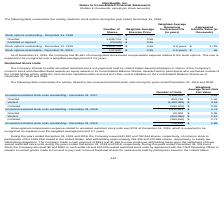According to Nanthealth's financial document, What is the value of unrecognized stock-based compensation expense related to the stock options at December 31, 2019? According to the financial document, $1,641 (in thousands). The relevant text states: "As of December 31, 2019, the Company had $1,641 of unrecognized stock-based compensation expense related to the stock options. This cost is..." Also, What are the respective stock options outstanding and exercisable at December 31, 2019? The document shows two values: 5,815,724 and 137,500. From the document: "Stock options exercisable - December 31, 2019 137,500 $ 0.55 9.6 years $ 66 Stock options outstanding - December 31, 2019 5,815,724 $ 0.56 9.6 years $..." Also, What are the weighted-average exercise price of the stock options outstanding and exercisable at December 31, 2019? The document shows two values: $0.56 and $0.55. From the document: "Granted 5,835,724 $ 0.56 Forfeited or expired (20,000) $ 0.55..." Also, can you calculate: What is the value of the stock options granted as a percentage of the total stock options outstanding as at December 31, 2019? Based on the calculation: 5,835,724/5,815,724 , the result is 100.34 (percentage). This is based on the information: "Stock options outstanding - December 31, 2019 5,815,724 $ 0.56 9.6 years $ 2,725 Granted 5,835,724 $ 0.56..." The key data points involved are: 5,815,724, 5,835,724. Also, can you calculate: What is the average number of stocks outstanding as at December 31, 2018 and 2019? To answer this question, I need to perform calculations using the financial data. The calculation is: (5,815,724 + 0)/2  , which equals 2907862. This is based on the information: "Stock options outstanding - December 31, 2018 — $ — Stock options outstanding - December 31, 2019 5,815,724 $ 0.56 9.6 years $ 2,725 Stock options outstanding - December 31, 2018 — $ —..." The key data points involved are: 5,815,724. Also, can you calculate: What is the total number of stocks outstanding as at December 31, 2018 and 2019? Based on the calculation: 5,815,724 + 0 , the result is 5815724. This is based on the information: "Stock options outstanding - December 31, 2019 5,815,724 $ 0.56 9.6 years $ 2,725 Stock options outstanding - December 31, 2019 5,815,724 $ 0.56 9.6 years $ 2,725..." The key data points involved are: 0, 5,815,724. 